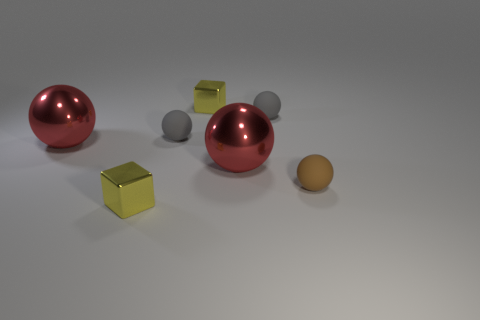Subtract all brown spheres. How many spheres are left? 4 Subtract all brown balls. How many balls are left? 4 Subtract all blue spheres. Subtract all yellow blocks. How many spheres are left? 5 Add 2 large red things. How many objects exist? 9 Subtract all balls. How many objects are left? 2 Subtract 0 brown cubes. How many objects are left? 7 Subtract all small yellow objects. Subtract all big red objects. How many objects are left? 3 Add 7 tiny gray spheres. How many tiny gray spheres are left? 9 Add 7 tiny gray rubber things. How many tiny gray rubber things exist? 9 